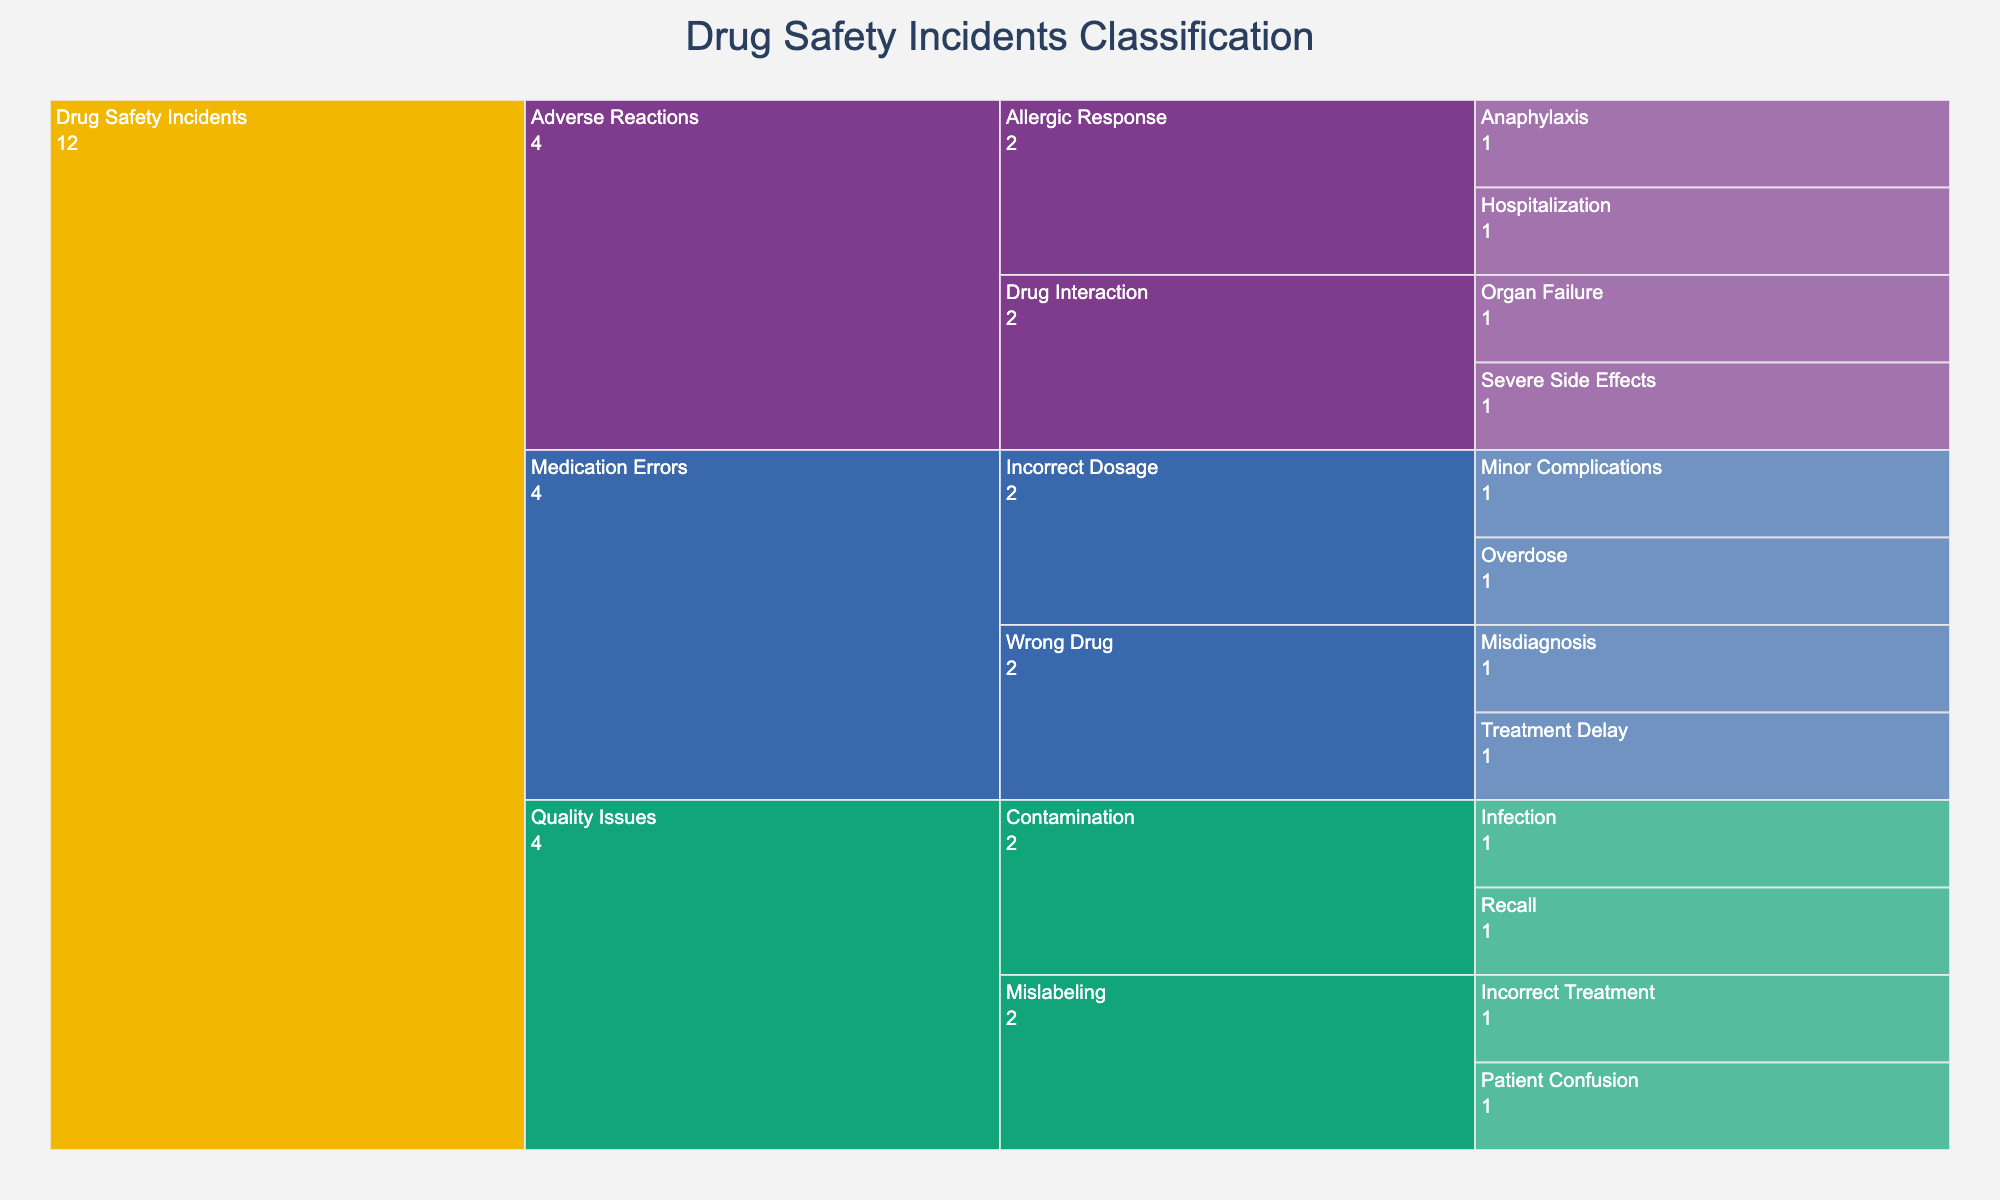How are drug safety incidents classified in the icicle chart? The icicle chart classifies drug safety incidents into three main types: 'Adverse Reactions,' 'Medication Errors,' and 'Quality Issues.' Each type further breaks down into causes and outcomes.
Answer: Into three main types: Adverse Reactions, Medication Errors, and Quality Issues Which type has the most subcategories of causes? From the icicle chart, 'Adverse Reactions' has the most subcategories of causes, which include 'Allergic Response' and 'Drug Interaction.'
Answer: Adverse Reactions What are the outcomes associated with 'Incorrect Dosage' under 'Medication Errors'? The icicle chart shows that 'Incorrect Dosage' under 'Medication Errors' has outcomes 'Minor Complications' and 'Overdose.'
Answer: Minor Complications and Overdose Which cause under 'Quality Issues' leads to a 'Recall'? According to the icicle chart, 'Contamination' under 'Quality Issues' leads to a 'Recall.'
Answer: Contamination Compare the outcomes of 'Allergic Response' under 'Adverse Reactions' and 'Mislabeling' under 'Quality Issues'. Which has more severe outcomes? 'Allergic Response' under 'Adverse Reactions' leads to 'Hospitalization' and 'Anaphylaxis,' while 'Mislabeling' under 'Quality Issues' results in 'Incorrect Treatment' and 'Patient Confusion.' 'Allergic Response' has more severe outcomes.
Answer: Allergic Response Which type of drug safety incident has 'Organ Failure' as an outcome? The icicle chart indicates that 'Organ Failure' is an outcome of 'Drug Interaction' under the 'Adverse Reactions' category.
Answer: Adverse Reactions Is 'Misdiagnosis' an outcome under 'Wrong Drug' or 'Incorrect Dosage' in 'Medication Errors'? 'Misdiagnosis' is an outcome under 'Wrong Drug' in the 'Medication Errors' category according to the icicle chart.
Answer: Wrong Drug What are the different outcomes listed under 'Adverse Reactions'? From the icicle chart, 'Adverse Reactions' lists 'Hospitalization,' 'Anaphylaxis,' 'Organ Failure,' and 'Severe Side Effects' as outcomes.
Answer: Hospitalization, Anaphylaxis, Organ Failure, Severe Side Effects Identify the common cause(s) found under both 'Adverse Reactions' and 'Quality Issues.' Based on the icicle chart, there is no common cause listed under both 'Adverse Reactions' and 'Quality Issues.'
Answer: None What percentage of causes under 'Medication Errors' results in 'Severe Side Effects'? 'Severe Side Effects' is not an outcome listed under 'Medication Errors,' so 0% of causes in this category result in 'Severe Side Effects.'
Answer: 0% 